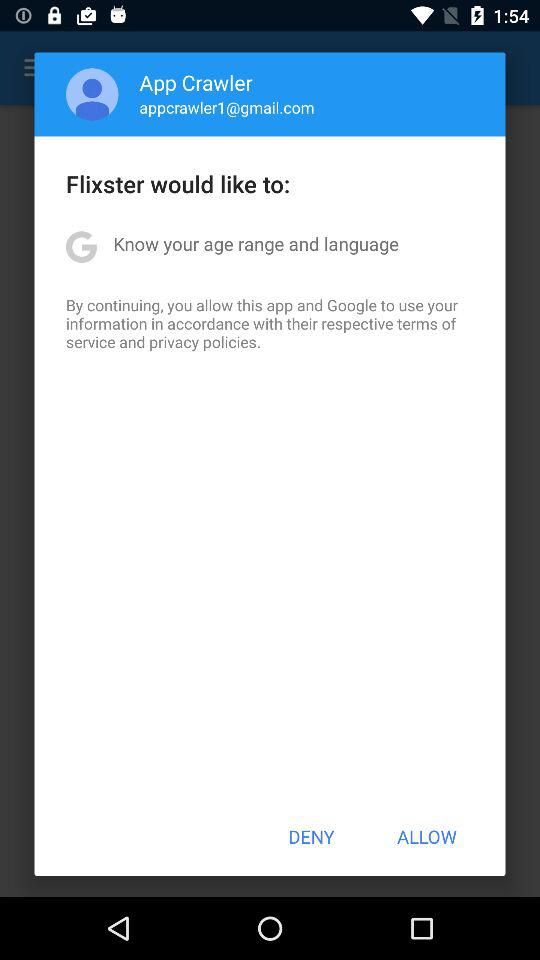What is the email address? The email address is appcrawler1@gmail.com. 